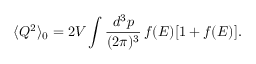<formula> <loc_0><loc_0><loc_500><loc_500>\langle Q ^ { 2 } \rangle _ { 0 } = 2 V \int { \frac { d ^ { 3 } p } { ( 2 \pi ) ^ { 3 } } } \, f ( E ) [ 1 + f ( E ) ] .</formula> 